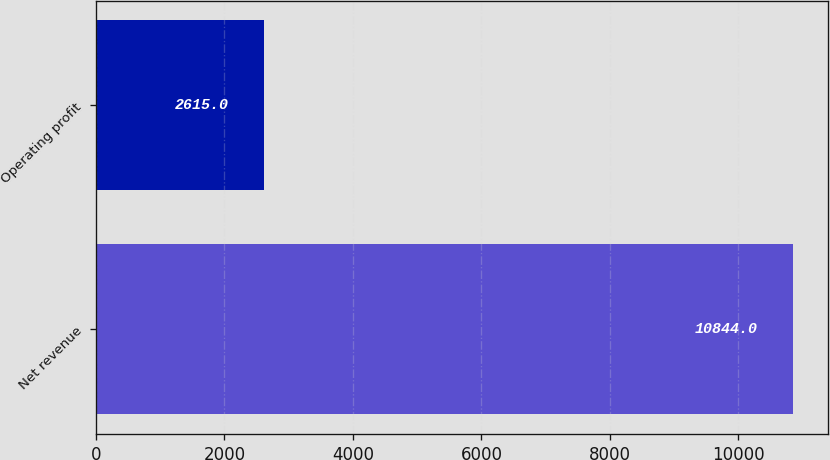Convert chart. <chart><loc_0><loc_0><loc_500><loc_500><bar_chart><fcel>Net revenue<fcel>Operating profit<nl><fcel>10844<fcel>2615<nl></chart> 